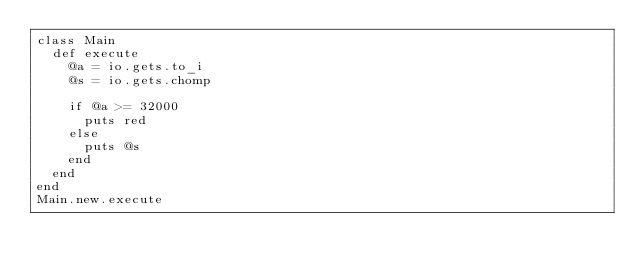Convert code to text. <code><loc_0><loc_0><loc_500><loc_500><_Ruby_>class Main
  def execute
    @a = io.gets.to_i
    @s = io.gets.chomp

    if @a >= 32000
      puts red
    else
      puts @s
    end
  end
end
Main.new.execute</code> 